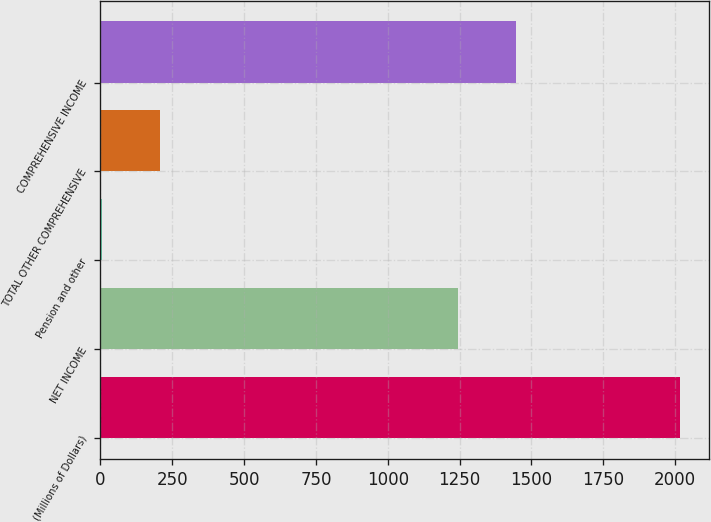Convert chart. <chart><loc_0><loc_0><loc_500><loc_500><bar_chart><fcel>(Millions of Dollars)<fcel>NET INCOME<fcel>Pension and other<fcel>TOTAL OTHER COMPREHENSIVE<fcel>COMPREHENSIVE INCOME<nl><fcel>2016<fcel>1245<fcel>7<fcel>207.9<fcel>1445.9<nl></chart> 